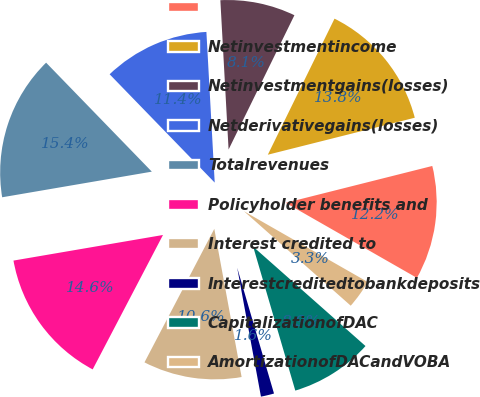<chart> <loc_0><loc_0><loc_500><loc_500><pie_chart><ecel><fcel>Netinvestmentincome<fcel>Netinvestmentgains(losses)<fcel>Netderivativegains(losses)<fcel>Totalrevenues<fcel>Policyholder benefits and<fcel>Interest credited to<fcel>Interestcreditedtobankdeposits<fcel>CapitalizationofDAC<fcel>AmortizationofDACandVOBA<nl><fcel>12.19%<fcel>13.82%<fcel>8.13%<fcel>11.38%<fcel>15.44%<fcel>14.63%<fcel>10.57%<fcel>1.63%<fcel>8.94%<fcel>3.26%<nl></chart> 